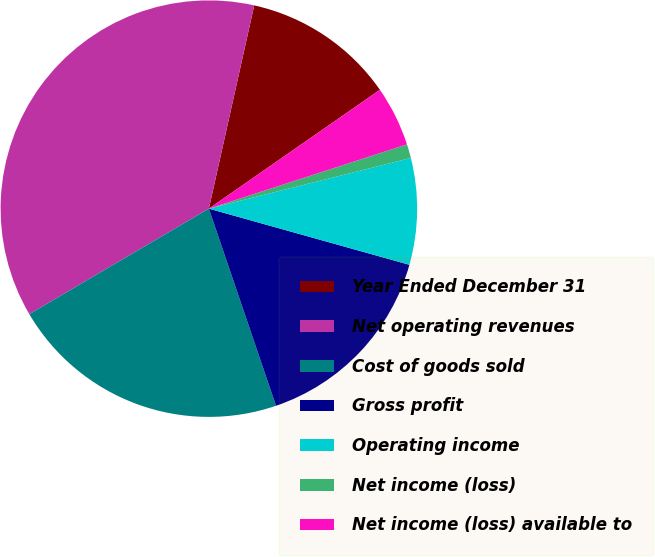<chart> <loc_0><loc_0><loc_500><loc_500><pie_chart><fcel>Year Ended December 31<fcel>Net operating revenues<fcel>Cost of goods sold<fcel>Gross profit<fcel>Operating income<fcel>Net income (loss)<fcel>Net income (loss) available to<nl><fcel>11.84%<fcel>36.95%<fcel>21.77%<fcel>15.43%<fcel>8.26%<fcel>1.08%<fcel>4.67%<nl></chart> 